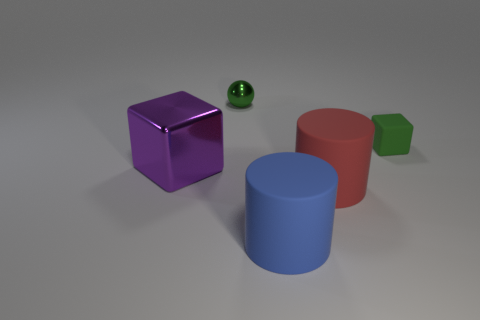What number of things are shiny things that are behind the green matte block or large objects that are in front of the red rubber cylinder? In the image, one shiny object, a green sphere, is positioned behind the green matte block. Additionally, there is a single large blue cylinder situated in front of the red rubber cylinder. Therefore, the total count of items specified by the question is two. 